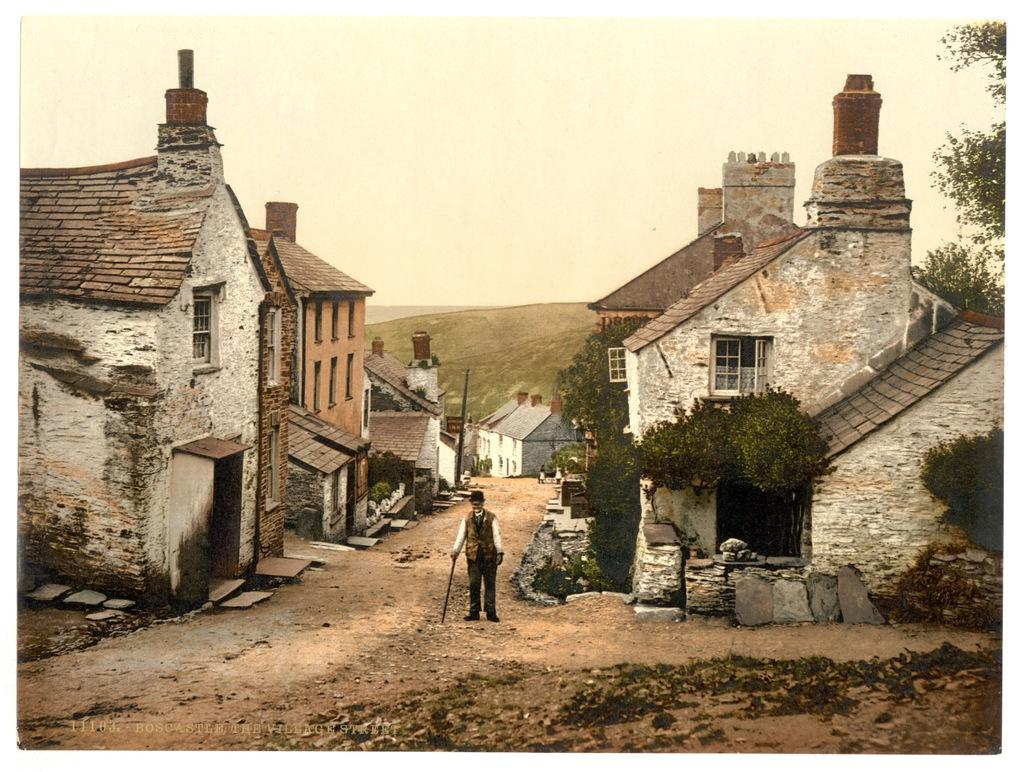What is the man in the image doing? The man is standing in the image. What is the man holding in the image? The man is holding a stick in the image. What type of headwear is the man wearing? The man is wearing a hat in the image. What type of structures can be seen in the image? There are houses visible in the image. What type of vegetation can be seen in the image? There are trees in the image. What is visible in the background of the image? There is a hill and the sky visible in the background of the image. How many snakes are wrapped around the man's legs in the image? There are no snakes present in the image; the man is holding a stick. What type of chair is the man sitting on in the image? The man is standing in the image, so there is no chair present. 